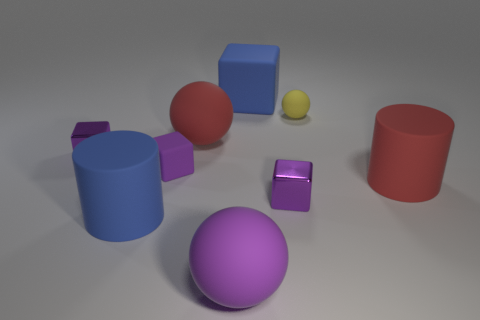Subtract all purple spheres. How many purple cubes are left? 3 Subtract all cylinders. How many objects are left? 7 Add 8 small rubber cubes. How many small rubber cubes exist? 9 Subtract 2 purple blocks. How many objects are left? 7 Subtract all big red things. Subtract all tiny matte cubes. How many objects are left? 6 Add 9 purple matte balls. How many purple matte balls are left? 10 